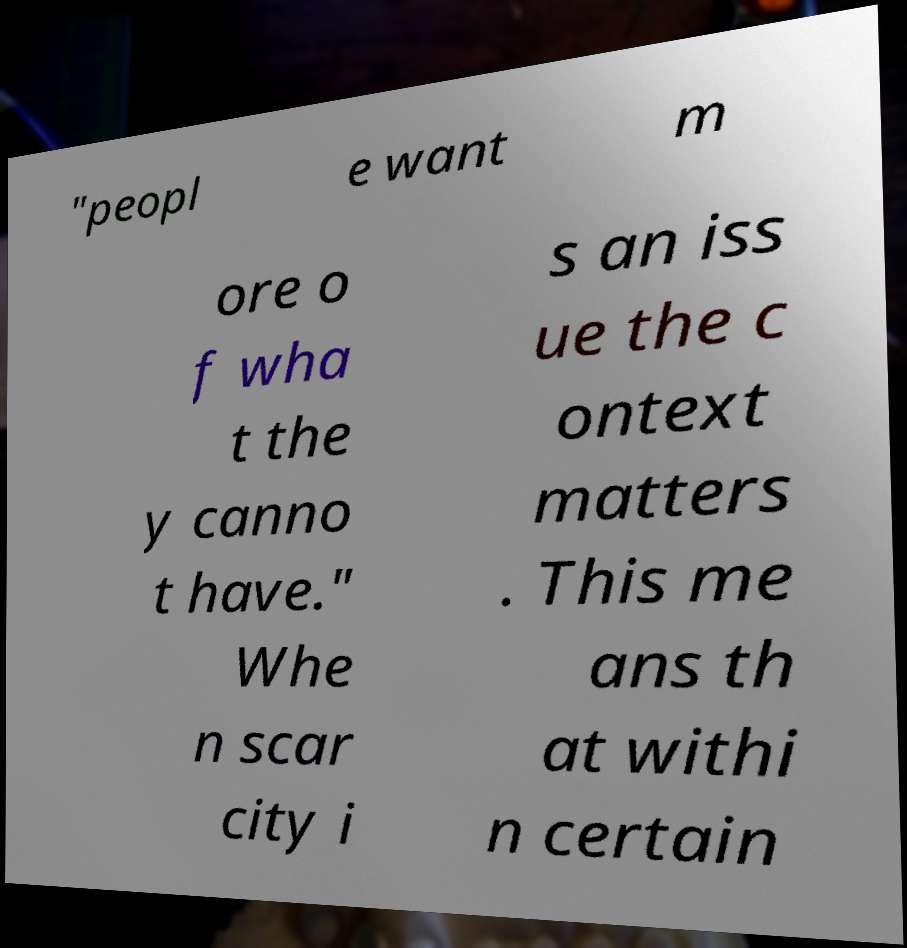Could you extract and type out the text from this image? "peopl e want m ore o f wha t the y canno t have." Whe n scar city i s an iss ue the c ontext matters . This me ans th at withi n certain 